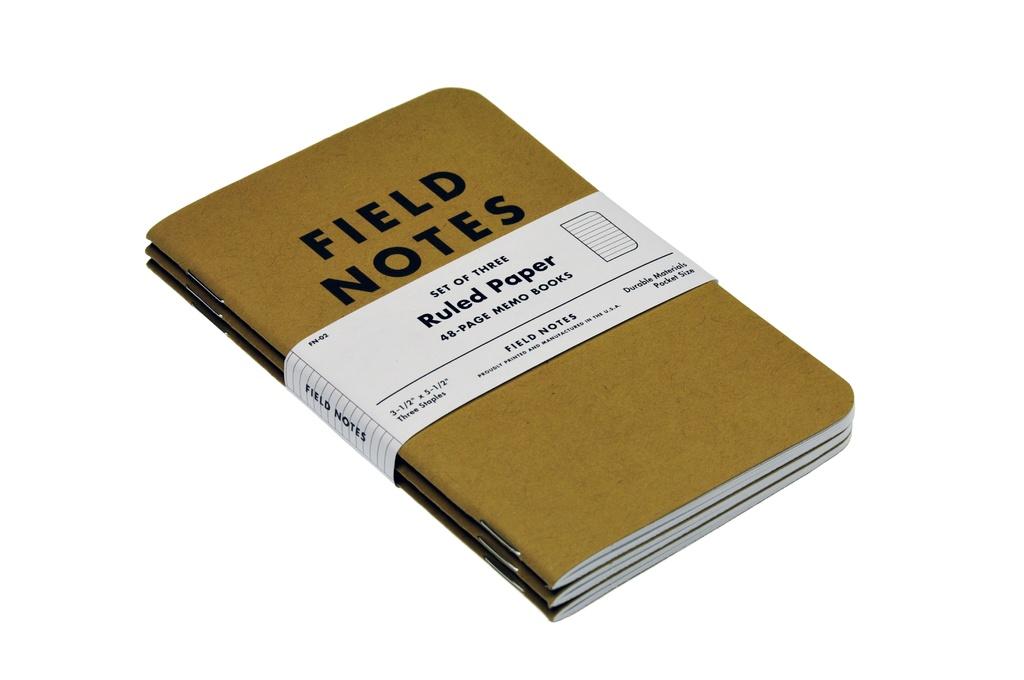What kind of notes is this book for?
Your answer should be compact. Field notes. 